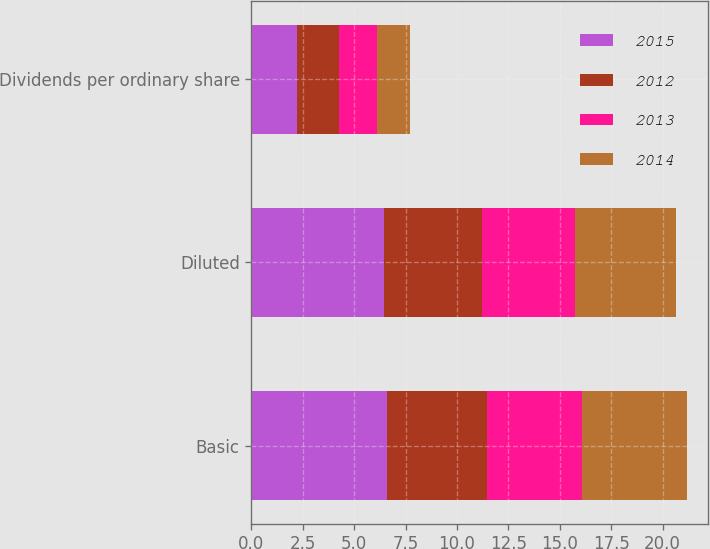<chart> <loc_0><loc_0><loc_500><loc_500><stacked_bar_chart><ecel><fcel>Basic<fcel>Diluted<fcel>Dividends per ordinary share<nl><fcel>2015<fcel>6.58<fcel>6.45<fcel>2.2<nl><fcel>2012<fcel>4.87<fcel>4.76<fcel>2.04<nl><fcel>2013<fcel>4.64<fcel>4.52<fcel>1.86<nl><fcel>2014<fcel>5.08<fcel>4.93<fcel>1.62<nl></chart> 